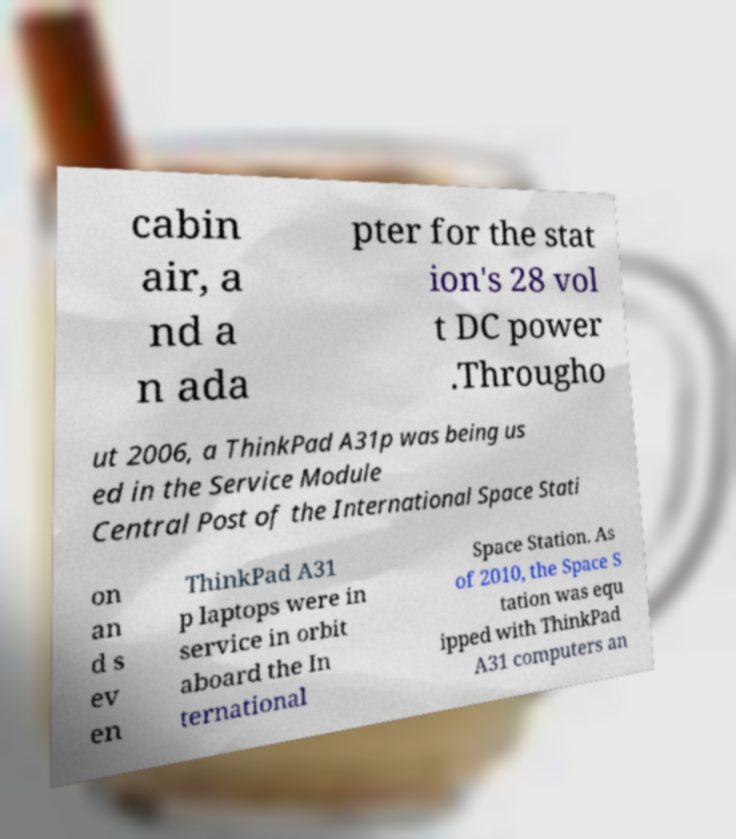Can you accurately transcribe the text from the provided image for me? cabin air, a nd a n ada pter for the stat ion's 28 vol t DC power .Througho ut 2006, a ThinkPad A31p was being us ed in the Service Module Central Post of the International Space Stati on an d s ev en ThinkPad A31 p laptops were in service in orbit aboard the In ternational Space Station. As of 2010, the Space S tation was equ ipped with ThinkPad A31 computers an 